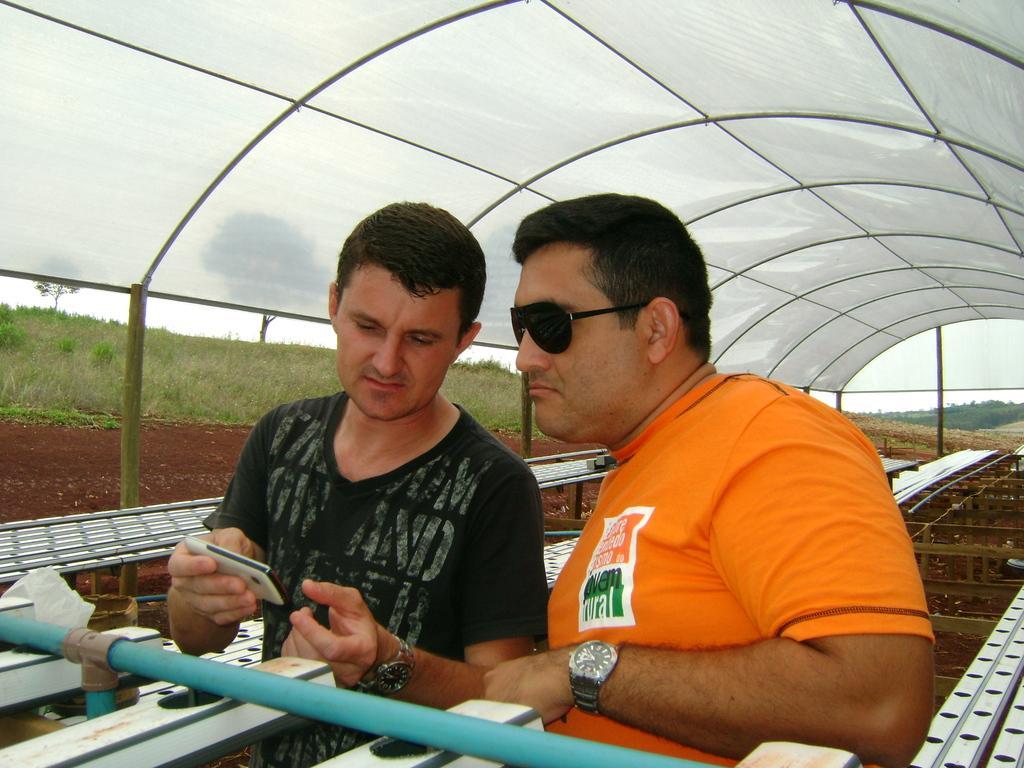How would you summarize this image in a sentence or two? In the center of the image there are two people. The man standing on the left is holding a mobile in his hand, next to him there is another man wearing glasses. At the top there is a shed. In the background we can see grass and trees. 